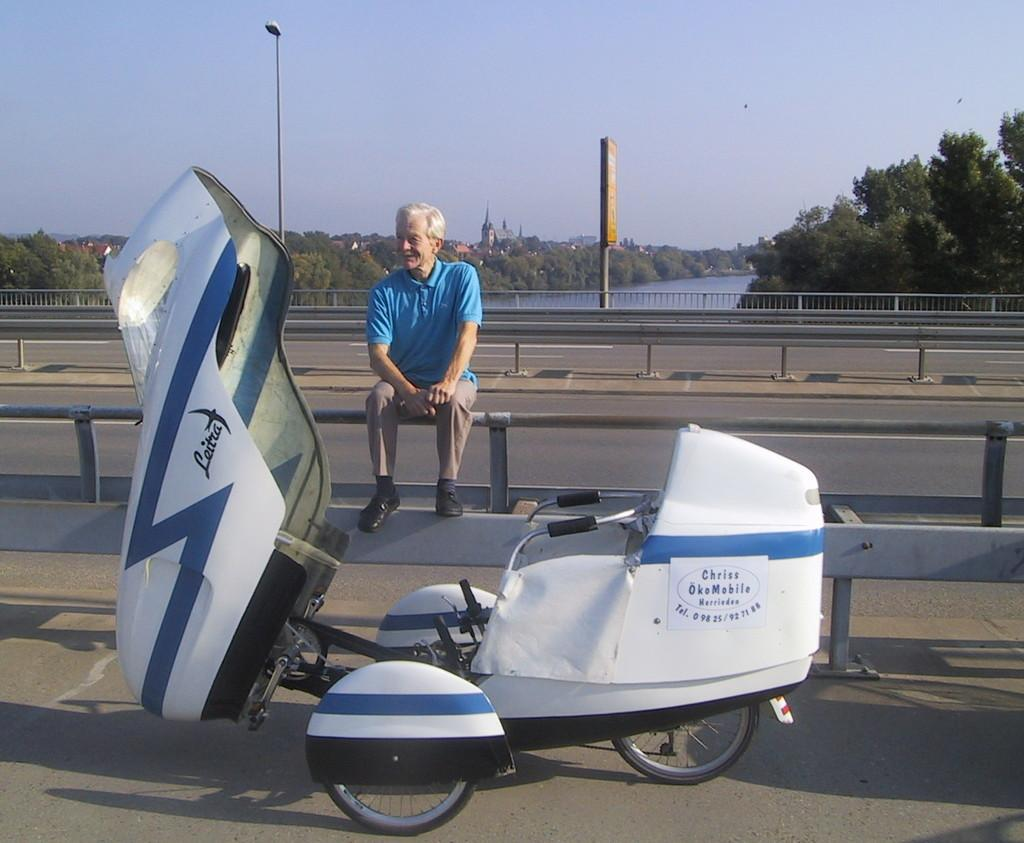<image>
Present a compact description of the photo's key features. A man sits on a railing next to a vehicle with the words Chriss OkoMobile on the side. 